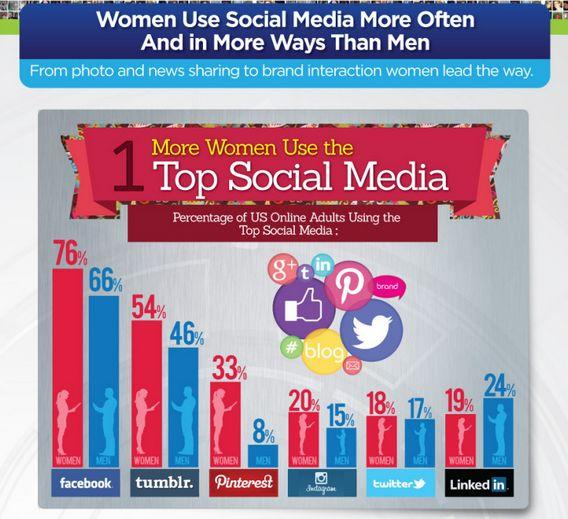Mention a couple of crucial points in this snapshot. Pinterest is the least used social media tool among men, according to data. LinkedIn is the second least commonly used social media tool among women. 